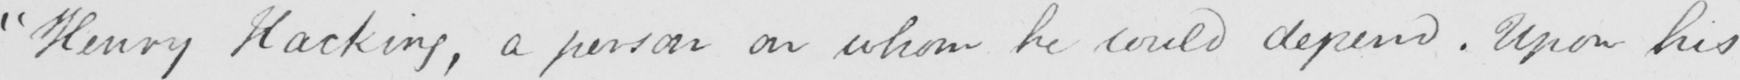Transcribe the text shown in this historical manuscript line. " Henry Hacking , a person on whom he could depend . Upon his 